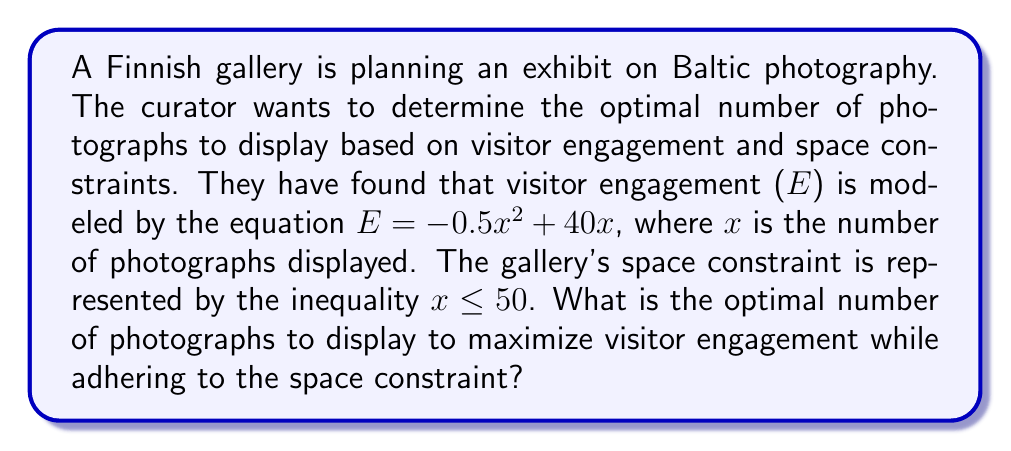Could you help me with this problem? To solve this problem, we need to find the maximum value of the quadratic function $E = -0.5x^2 + 40x$ within the domain $0 \leq x \leq 50$.

1. First, let's find the vertex of the parabola, which represents the maximum point:
   
   The x-coordinate of the vertex is given by $x = -\frac{b}{2a}$, where $a = -0.5$ and $b = 40$.
   
   $$x = -\frac{40}{2(-0.5)} = \frac{40}{1} = 40$$

2. Now we need to check if this value satisfies the space constraint:
   
   $40 \leq 50$, so the optimal point is within the allowed range.

3. To verify that this is indeed a maximum (not a minimum), we can check the coefficient of $x^2$:
   
   The coefficient $a = -0.5 < 0$, confirming that the parabola opens downward and has a maximum.

4. Since the optimal point is within the allowed range and represents the maximum of the function, we can conclude that 40 photographs will maximize visitor engagement.

5. We can calculate the maximum engagement for verification:
   
   $$E = -0.5(40)^2 + 40(40) = -800 + 1600 = 800$$

Therefore, the optimal number of photographs to display is 40, which will result in a maximum engagement score of 800.
Answer: The optimal number of photographs to display is 40. 